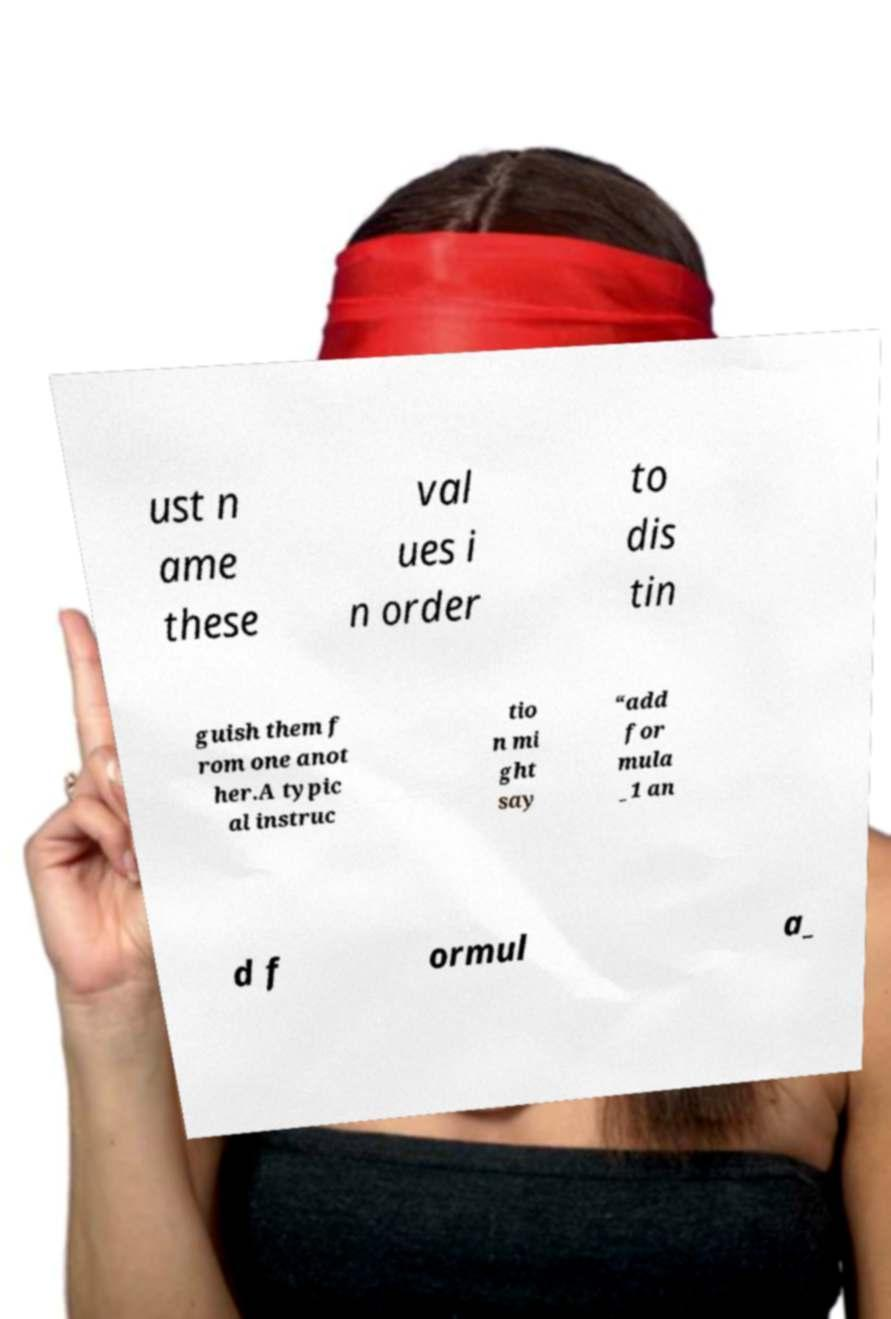There's text embedded in this image that I need extracted. Can you transcribe it verbatim? ust n ame these val ues i n order to dis tin guish them f rom one anot her.A typic al instruc tio n mi ght say “add for mula _1 an d f ormul a_ 